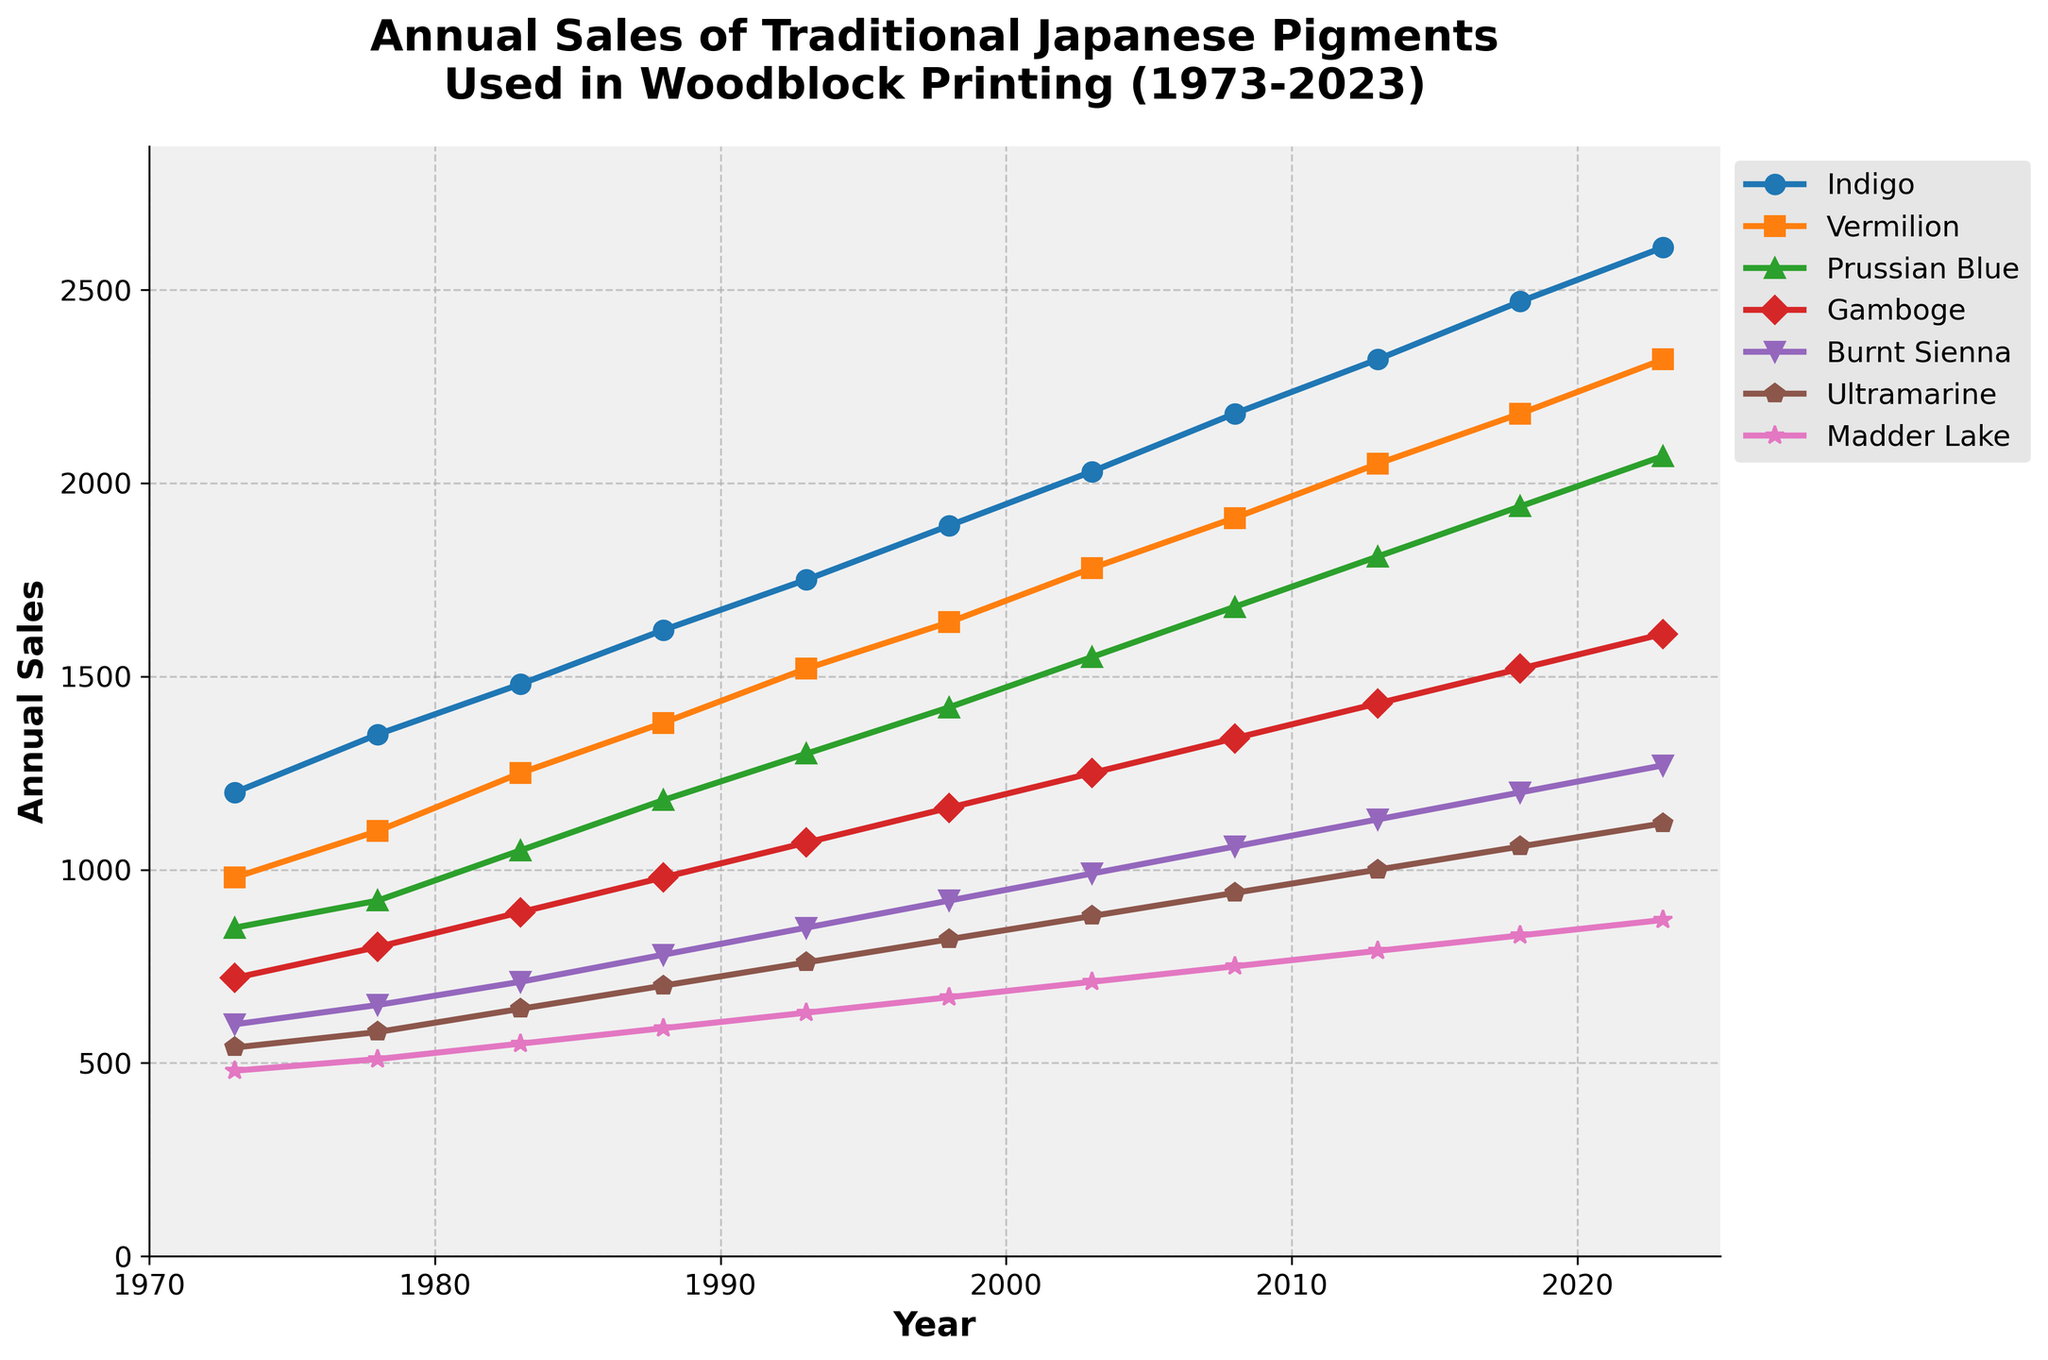What's the trend in the annual sales of Vermilion from 1973 to 2023? To assess the trend, look at how the sales values change over the years. The sales of Vermilion increase steadily from 980 units in 1973 to 2320 units in 2023.
Answer: Steady increase Which pigment experienced the largest increase in sales between 1973 and 2023? Calculate the difference in sales from 1973 to 2023 for each pigment. The largest increase is for Indigo, going from 1200 to 2610 units, which is a 1410 units increase.
Answer: Indigo By how much did the sales of Ultramarine increase from 1973 to 2023? Subtract the sales value of Ultramarine in 1973 from that in 2023: 1120 - 540 = 580 units.
Answer: 580 units How do the sales of Madder Lake in 2023 compare to the sales of Gamboge in 2013? Compare the two values directly. The sales of Madder Lake in 2023 are 870 units and the sales of Gamboge in 2013 are 1430 units, so Madder Lake's sales are lower.
Answer: Lower Which year did Burnt Sienna sales first exceed 1000 units? Identify the first year Burnt Sienna’s sales surpass 1000 units by checking the sales values: 2003 is the first year with 1060 units.
Answer: 2003 Order the pigments by their sales figures in 2023, from highest to lowest. List the sales figures in 2023 and sort them: Indigo (2610), Vermilion (2320), Prussian Blue (2070), Gamboge (1610), Burnt Sienna (1270), Ultramarine (1120), Madder Lake (870).
Answer: Indigo, Vermilion, Prussian Blue, Gamboge, Burnt Sienna, Ultramarine, Madder Lake What is the average annual sales of Prussian Blue over the 50 years? Sum all sales of Prussian Blue and divide by 11 (number of data points): (850 + 920 + 1050 + 1180 + 1300 + 1420 + 1550 + 1680 + 1810 + 1940 + 2070) / 11 = 1427.73 units.
Answer: 1427.73 units In which decade did the Gamboge pigment see the least growth in sales? Determine the growth in each decade and find the smallest increment. Growth rates: 70-80 (80), 80-90 (90), 90-00 (80), 00-10 (90), 10-20 (90), 20-30 (90). Least growth is from 70s to 80s and 90s to 00s with 80 units.
Answer: 1970s-1980s and 1990s-2000s Which pigment's sales have consistently increased every 5 years without any decline? Check sales data for each pigment to see if their values increase every 5 years. Indigo, Vermilion, Prussian Blue, Gamboge, Burnt Sienna, Ultramarine, and Madder Lake all show consistent increases.
Answer: All pigments 